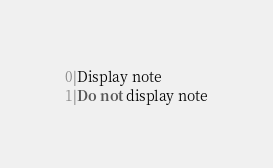Convert code to text. <code><loc_0><loc_0><loc_500><loc_500><_SQL_>0|Display note
1|Do not display note
</code> 